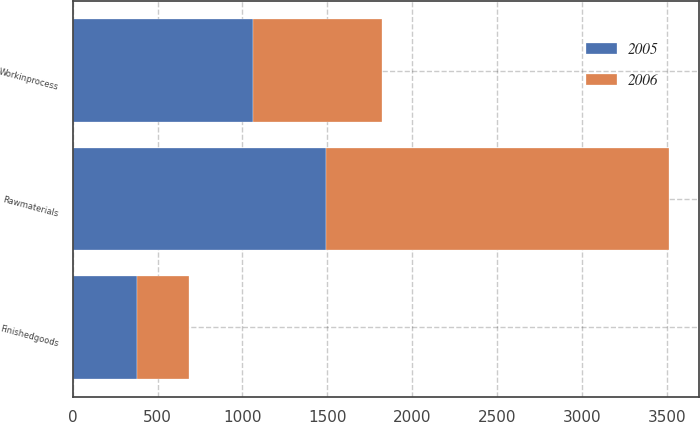Convert chart to OTSL. <chart><loc_0><loc_0><loc_500><loc_500><stacked_bar_chart><ecel><fcel>Rawmaterials<fcel>Workinprocess<fcel>Finishedgoods<nl><fcel>2006<fcel>2021<fcel>763<fcel>306<nl><fcel>2005<fcel>1492<fcel>1060<fcel>378<nl></chart> 